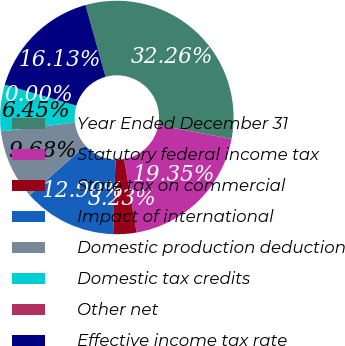Convert chart to OTSL. <chart><loc_0><loc_0><loc_500><loc_500><pie_chart><fcel>Year Ended December 31<fcel>Statutory federal income tax<fcel>State tax on commercial<fcel>Impact of international<fcel>Domestic production deduction<fcel>Domestic tax credits<fcel>Other net<fcel>Effective income tax rate<nl><fcel>32.26%<fcel>19.35%<fcel>3.23%<fcel>12.9%<fcel>9.68%<fcel>6.45%<fcel>0.0%<fcel>16.13%<nl></chart> 